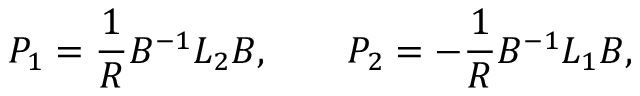<formula> <loc_0><loc_0><loc_500><loc_500>P _ { 1 } = { \frac { 1 } { R } } B ^ { - 1 } L _ { 2 } B , \quad P _ { 2 } = - { \frac { 1 } { R } } B ^ { - 1 } L _ { 1 } B ,</formula> 